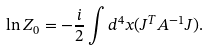<formula> <loc_0><loc_0><loc_500><loc_500>\ln Z _ { 0 } = - \frac { i } { 2 } \int { d } ^ { 4 } x ( J ^ { T } A ^ { - 1 } J ) .</formula> 